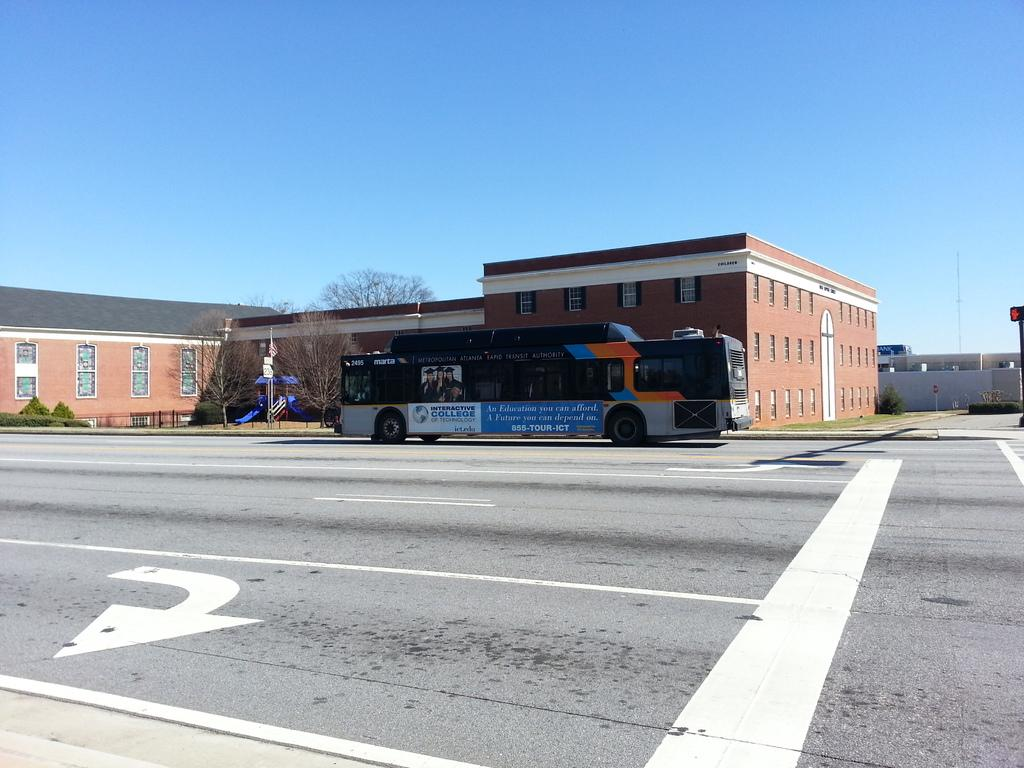What can be seen in the background of the image? There is a clear blue sky in the background of the image. What type of structure is present in the image? There is a building with windows in the image. What mode of transportation is visible on the road? There is a bus on the road in the image. What type of vegetation is present at the right side of the picture? There is a plant at the right side of the picture. What architectural feature is present at the right side of the picture? There is a wall at the right side of the picture. How many cherries are hanging from the wall in the image? There are no cherries present in the image; it features a plant and a wall. What type of drawer is visible in the image? There is no drawer present in the image. 